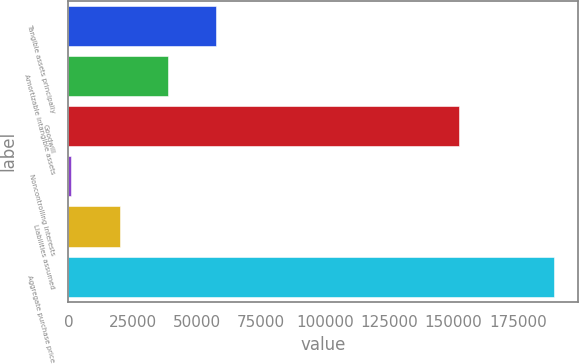Convert chart to OTSL. <chart><loc_0><loc_0><loc_500><loc_500><bar_chart><fcel>Tangible assets principally<fcel>Amortizable intangible assets<fcel>Goodwill<fcel>Noncontrolling interests<fcel>Liabilities assumed<fcel>Aggregate purchase price<nl><fcel>57505<fcel>38727<fcel>152252<fcel>1171<fcel>19949<fcel>188951<nl></chart> 